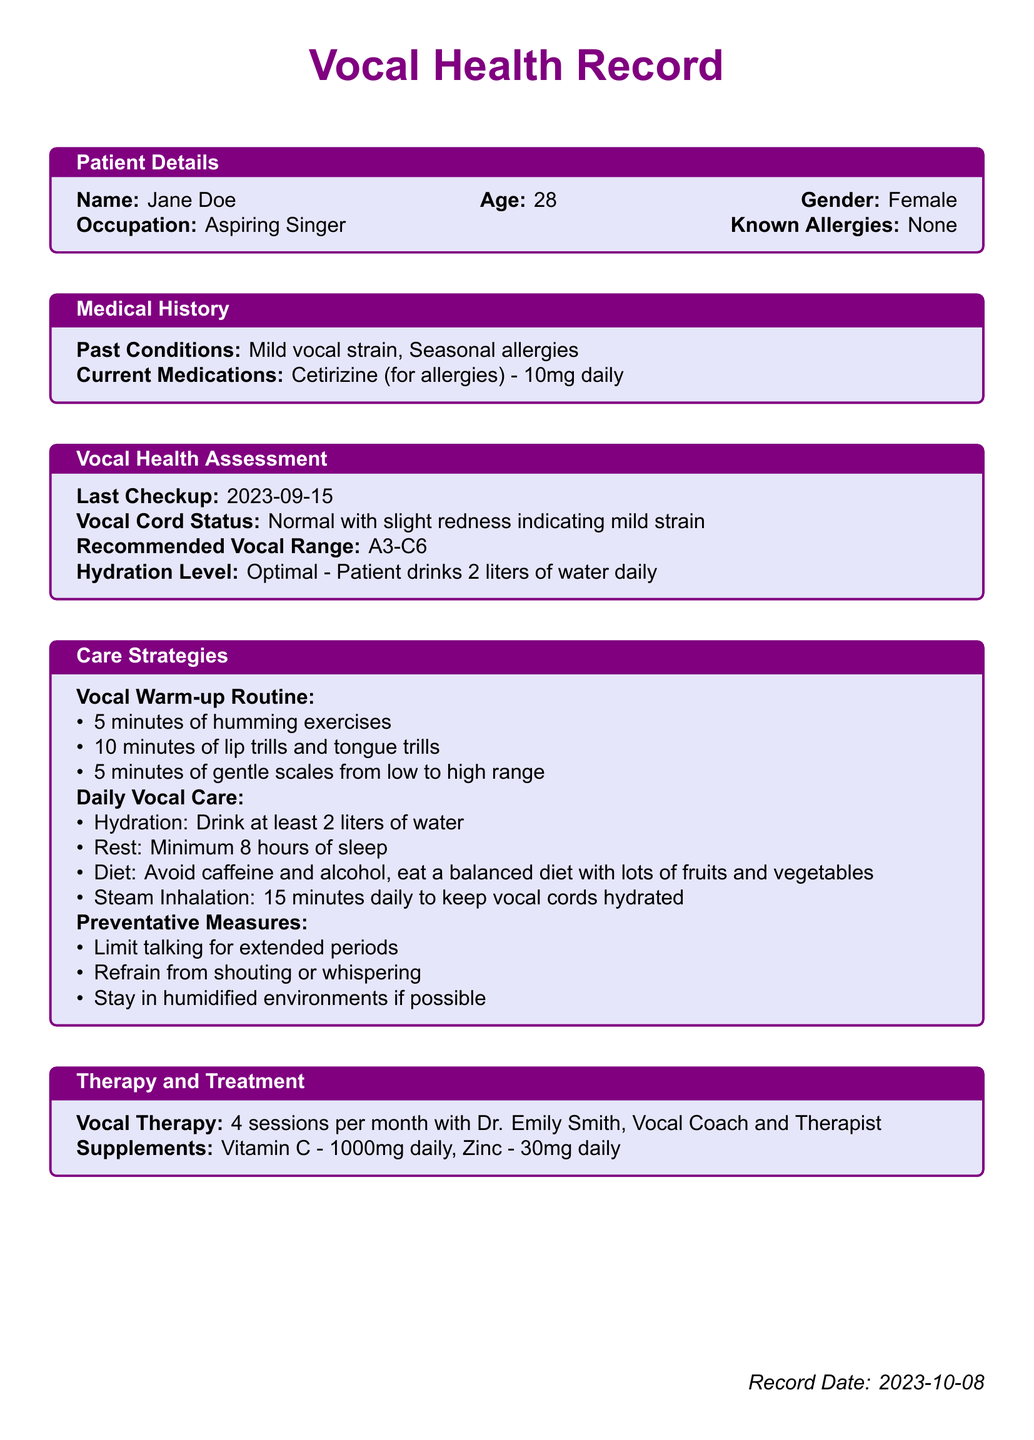What is the patient's name? The patient's name is listed in the Patient Details section of the document.
Answer: Jane Doe What is the patient's age? The patient's age is found in the Patient Details section of the document.
Answer: 28 What is the last checkup date? The last checkup date is mentioned in the Vocal Health Assessment section.
Answer: 2023-09-15 What is the recommended vocal range? The recommended vocal range is specified in the Vocal Health Assessment section.
Answer: A3-C6 How many sessions of vocal therapy does the patient receive per month? The number of vocal therapy sessions is indicated in the Therapy and Treatment section.
Answer: 4 sessions What is the daily hydration target for the patient? The daily hydration target is stated in the Daily Vocal Care section of the document.
Answer: 2 liters What is one of the preventative measures advised for the patient? The preventative measures are listed in the Care Strategies section, and one example can be found there.
Answer: Limit talking for extended periods What type of medication is the patient currently taking? The current medication is noted in the Medical History section of the document.
Answer: Cetirizine What supplements is the patient taking daily? The supplements taken daily by the patient are found in the Therapy and Treatment section.
Answer: Vitamin C - 1000mg daily, Zinc - 30mg daily 